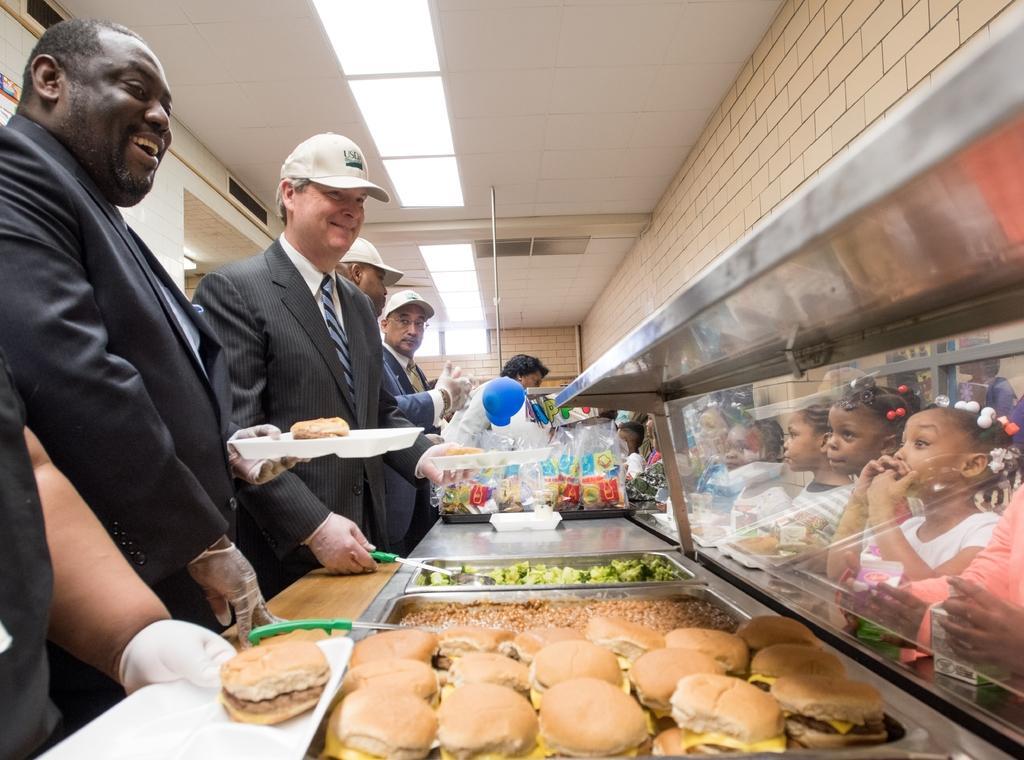Please provide a concise description of this image. In this picture I can see group of people standing. There are food items in the trays. I can see three persons holding the plates, and in the background there are covers, lights and some other objects. 